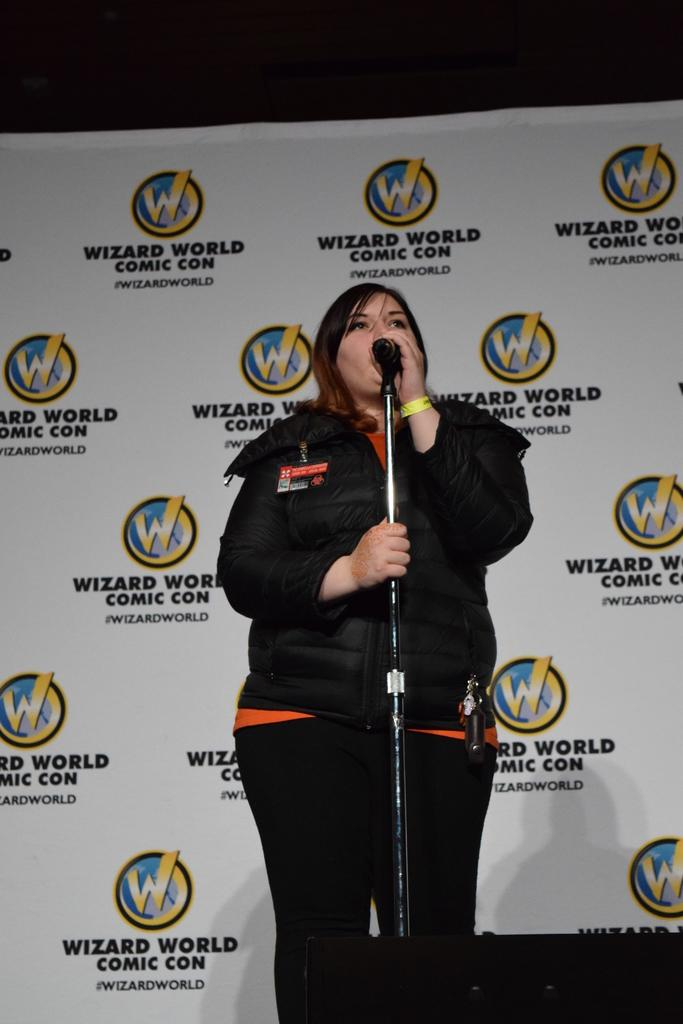Who is the main subject in the image? There is a woman in the image. What object is visible near the woman? There is a microphone in the image. What can be seen in the background of the image? There is a banner in the background of the image. What type of food is the woman preparing in the image? There is no food present in the image, as it features a woman with a microphone and a banner in the background. 